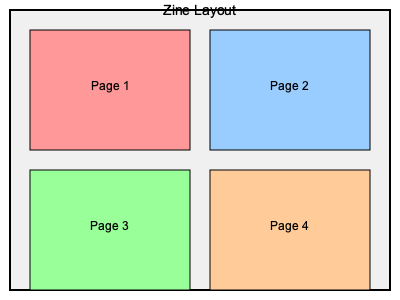In creating a cohesive visual style across multiple Zine pages using color theory and typography, which color harmony scheme would be most effective for unifying the layout shown in the diagram, while maintaining visual interest and supporting the emotional tone of your friend's poems? To create a cohesive visual style across multiple Zine pages using color theory and typography, consider the following steps:

1. Analyze the content: Understand the emotional tone and themes of your friend's poems to inform your color choices.

2. Choose a color harmony scheme:
   a. Analogous: Colors adjacent on the color wheel, creating a harmonious and unified look.
   b. Complementary: Opposite colors on the color wheel, providing high contrast and visual interest.
   c. Triadic: Three colors equally spaced on the color wheel, offering balance and variety.
   d. Tetradic: Four colors arranged in two complementary pairs, providing rich color possibilities.

3. Consider the layout: The diagram shows four distinct pages, suggesting a need for both unity and variety.

4. Apply color theory:
   a. Use a dominant color as the base for all pages to create unity.
   b. Apply secondary and accent colors to individual pages for visual interest.
   c. Adjust saturation and value to create hierarchy and emphasis.

5. Implement typography:
   a. Choose a consistent typeface family for headings and body text across all pages.
   b. Use font weights and sizes to create visual hierarchy.
   c. Align typography with the chosen color scheme for cohesion.

6. Maintain balance: Ensure that the color distribution and typographic elements are balanced across all pages.

7. Consider the emotional impact: Select colors that reinforce the emotional tone of the poems.

Given these considerations, the most effective color harmony scheme for this layout would be a tetradic color scheme. This scheme provides:
- Enough variety to keep each page visually distinct
- A unified look through the use of four interrelated colors
- Rich color possibilities to support various emotional tones in the poems
- Flexibility to adjust saturation and value for hierarchy and emphasis

The tetradic scheme allows for a dominant color to unify the layout, while the other three colors can be used to differentiate pages and highlight specific elements, creating a cohesive yet visually interesting design that supports the poetic content.
Answer: Tetradic color scheme 